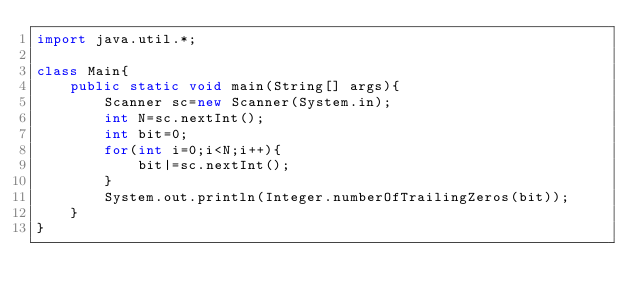<code> <loc_0><loc_0><loc_500><loc_500><_Java_>import java.util.*;

class Main{
    public static void main(String[] args){
        Scanner sc=new Scanner(System.in);
        int N=sc.nextInt();
        int bit=0;
        for(int i=0;i<N;i++){
            bit|=sc.nextInt();
        }
        System.out.println(Integer.numberOfTrailingZeros(bit));
    }
}</code> 